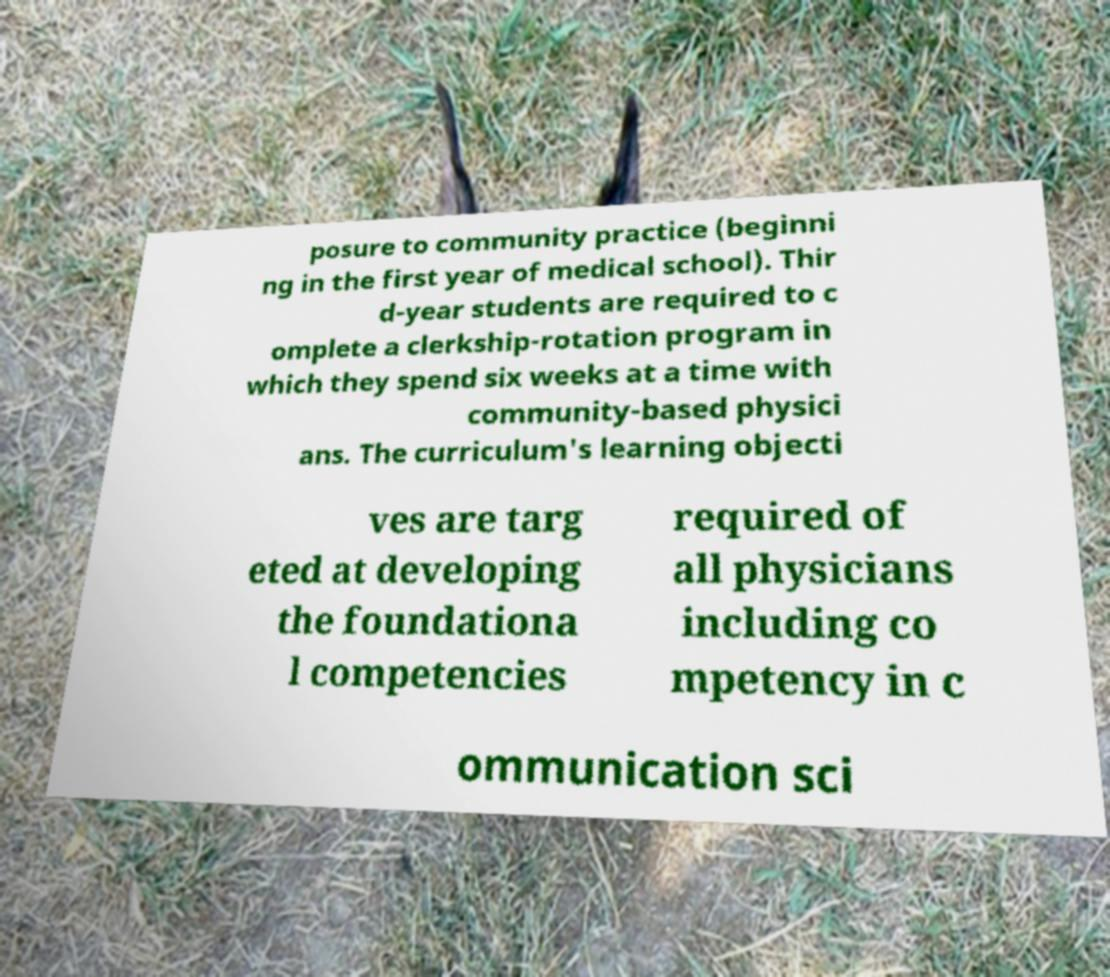Could you extract and type out the text from this image? posure to community practice (beginni ng in the first year of medical school). Thir d-year students are required to c omplete a clerkship-rotation program in which they spend six weeks at a time with community-based physici ans. The curriculum's learning objecti ves are targ eted at developing the foundationa l competencies required of all physicians including co mpetency in c ommunication sci 